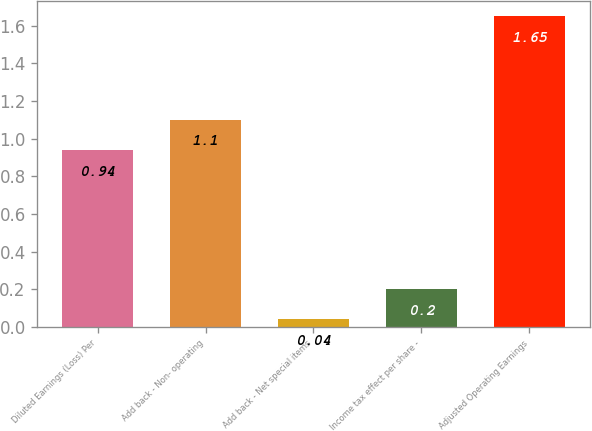<chart> <loc_0><loc_0><loc_500><loc_500><bar_chart><fcel>Diluted Earnings (Loss) Per<fcel>Add back - Non- operating<fcel>Add back - Net special items<fcel>Income tax effect per share -<fcel>Adjusted Operating Earnings<nl><fcel>0.94<fcel>1.1<fcel>0.04<fcel>0.2<fcel>1.65<nl></chart> 